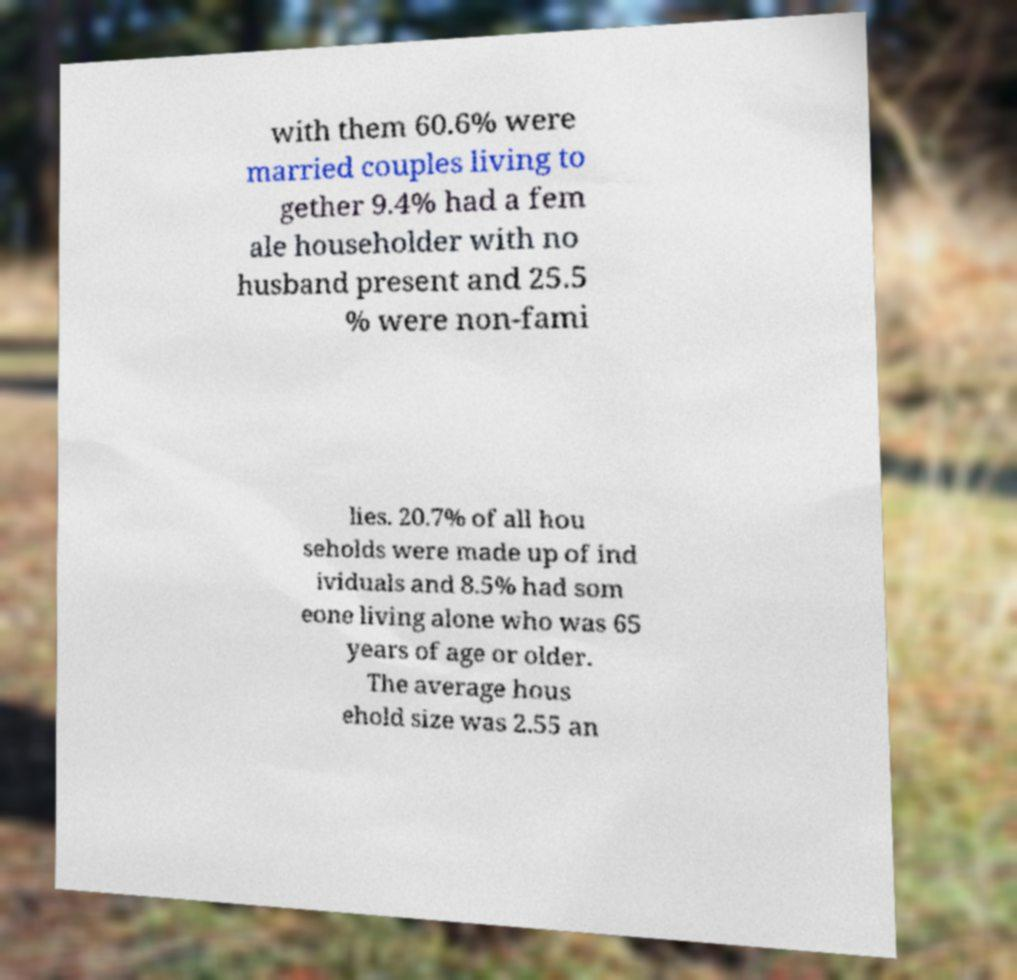I need the written content from this picture converted into text. Can you do that? with them 60.6% were married couples living to gether 9.4% had a fem ale householder with no husband present and 25.5 % were non-fami lies. 20.7% of all hou seholds were made up of ind ividuals and 8.5% had som eone living alone who was 65 years of age or older. The average hous ehold size was 2.55 an 